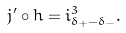Convert formula to latex. <formula><loc_0><loc_0><loc_500><loc_500>j ^ { \prime } \circ h = i ^ { 3 } _ { \delta _ { + } - \delta _ { - } } .</formula> 